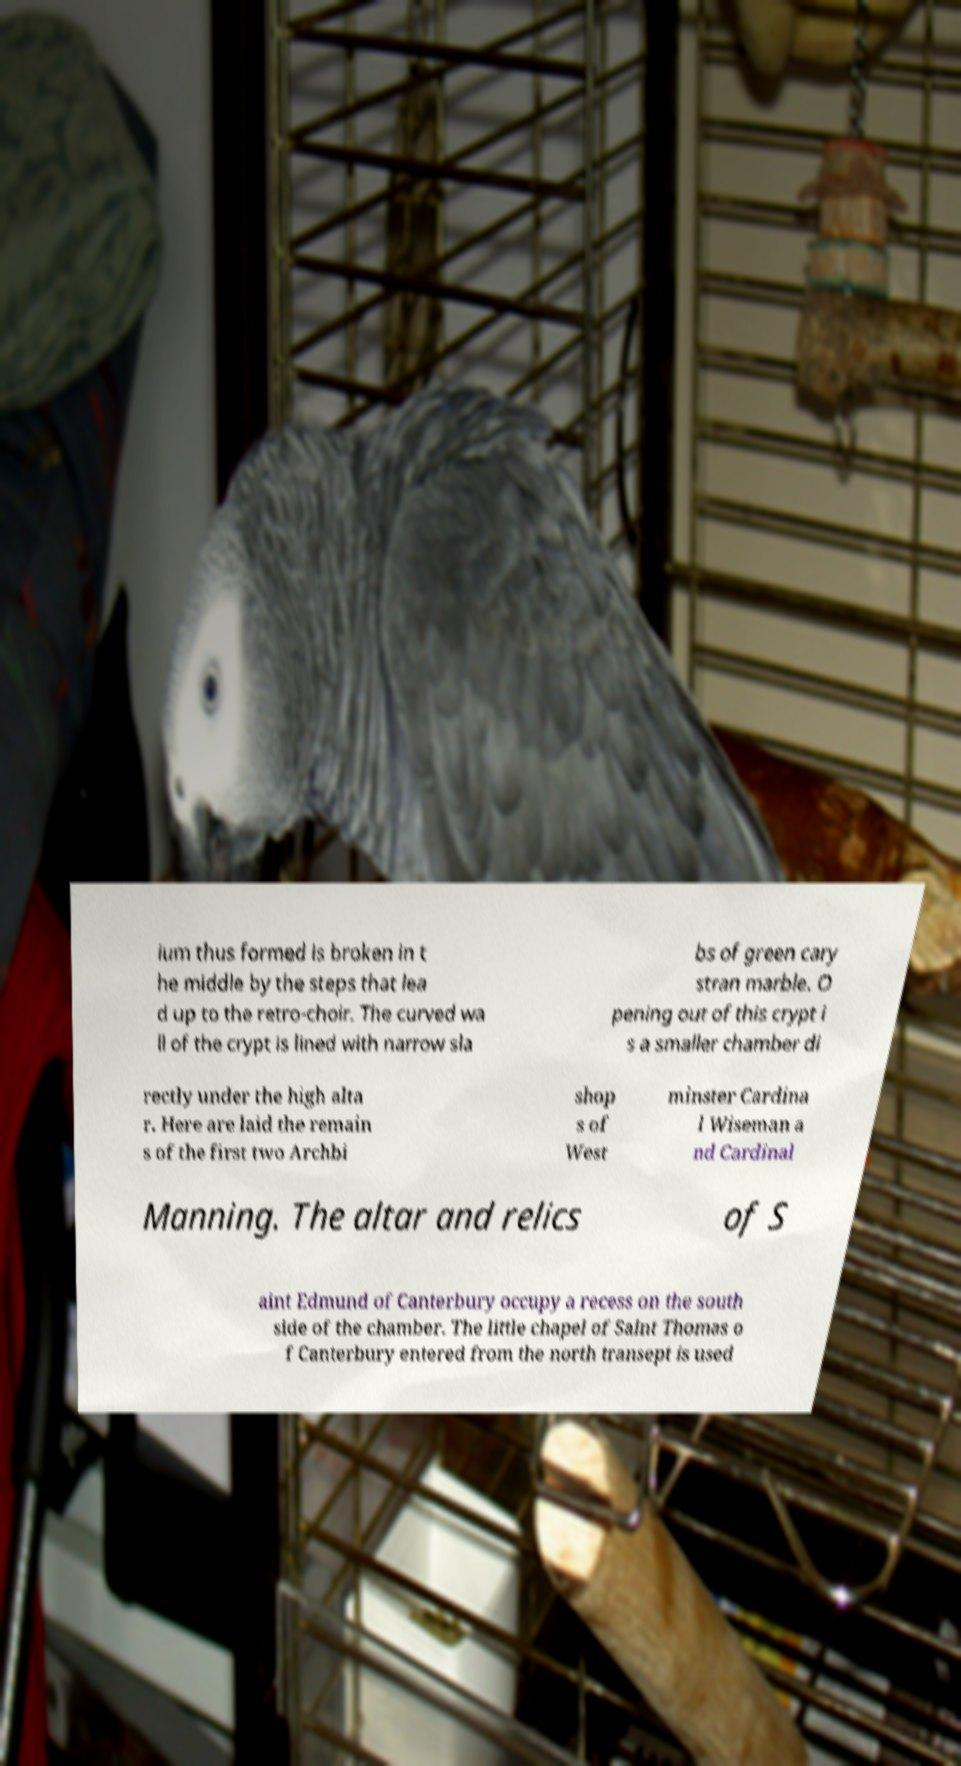Please identify and transcribe the text found in this image. ium thus formed is broken in t he middle by the steps that lea d up to the retro-choir. The curved wa ll of the crypt is lined with narrow sla bs of green cary stran marble. O pening out of this crypt i s a smaller chamber di rectly under the high alta r. Here are laid the remain s of the first two Archbi shop s of West minster Cardina l Wiseman a nd Cardinal Manning. The altar and relics of S aint Edmund of Canterbury occupy a recess on the south side of the chamber. The little chapel of Saint Thomas o f Canterbury entered from the north transept is used 